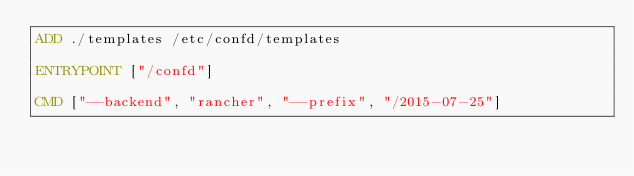<code> <loc_0><loc_0><loc_500><loc_500><_Dockerfile_>ADD ./templates /etc/confd/templates

ENTRYPOINT ["/confd"]

CMD ["--backend", "rancher", "--prefix", "/2015-07-25"]
</code> 